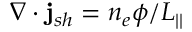<formula> <loc_0><loc_0><loc_500><loc_500>\nabla \cdot j _ { s h } = n _ { e } \phi / L _ { | | }</formula> 